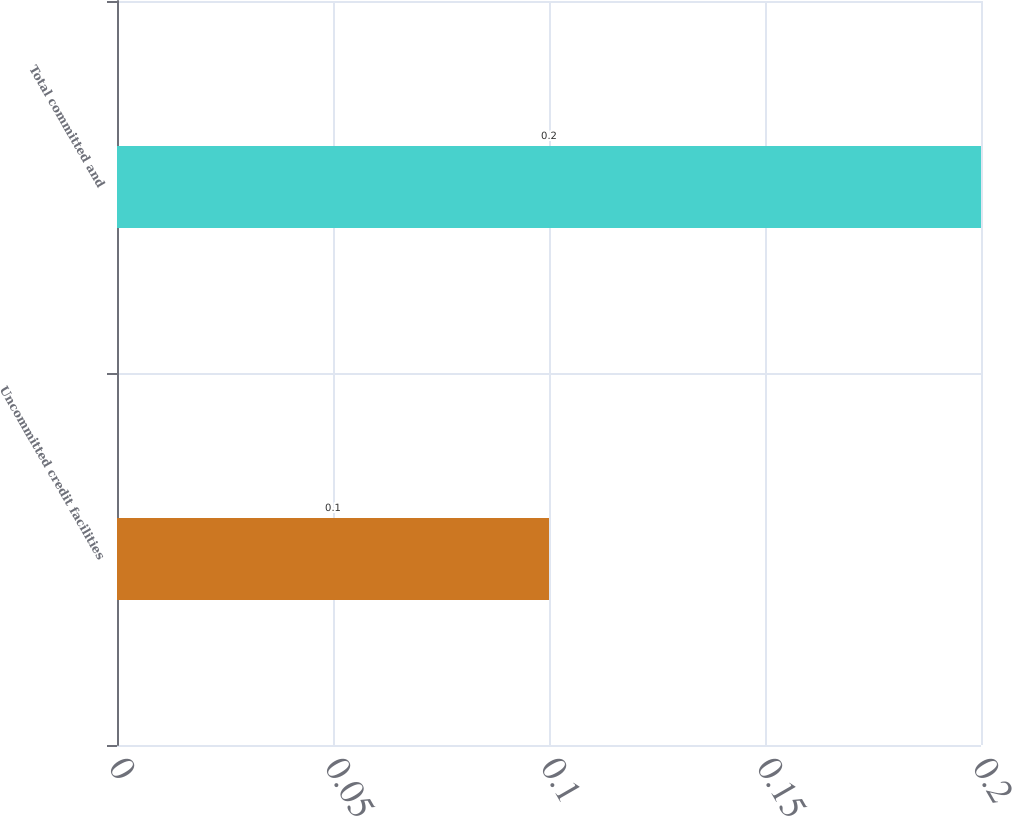Convert chart to OTSL. <chart><loc_0><loc_0><loc_500><loc_500><bar_chart><fcel>Uncommitted credit facilities<fcel>Total committed and<nl><fcel>0.1<fcel>0.2<nl></chart> 